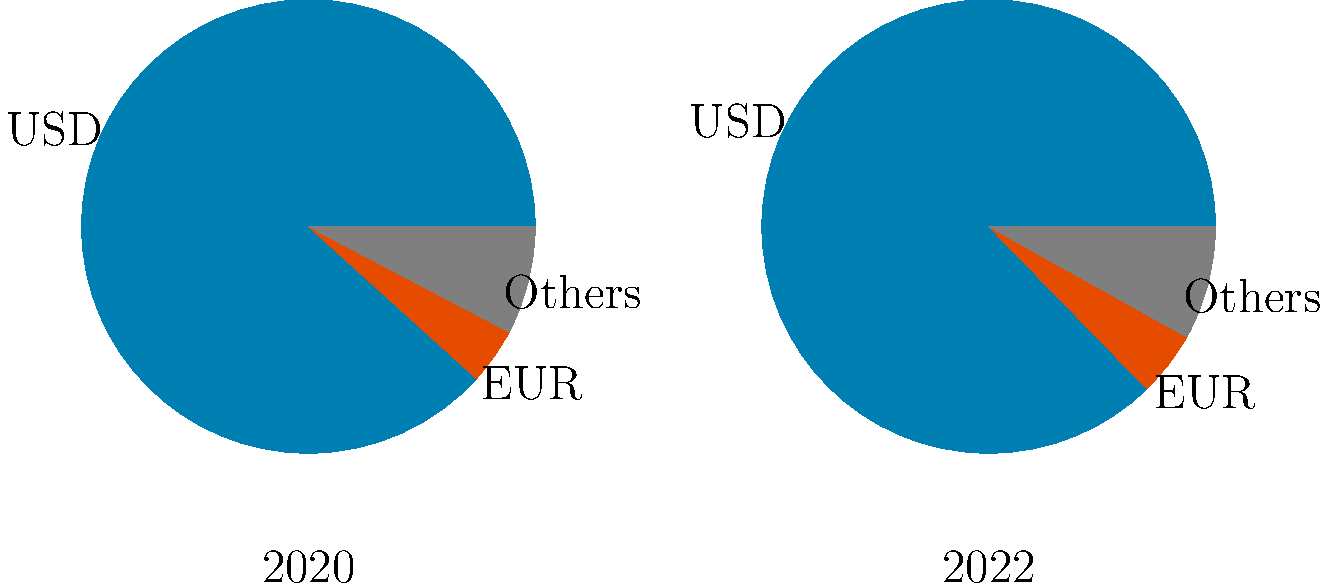Based on the pie charts showing global forex market share by currency for 2020 and 2022, which of the following statements is correct? Let's analyze the pie charts step by step:

1. USD (Blue):
   2020: 88.3%
   2022: 87.3%
   Change: Decreased by 1 percentage point

2. EUR (Orange):
   2020: 4.0%
   2022: 4.6%
   Change: Increased by 0.6 percentage points

3. Others (Gray):
   2020: 7.7%
   2022: 8.1%
   Change: Increased by 0.4 percentage points

Key observations:
- The USD remains the dominant currency in both years, but its share slightly decreased.
- Both EUR and Others categories increased their market share.
- The EUR showed the largest relative increase, growing from 4.0% to 4.6% (a 15% relative increase).
- The overall changes are relatively small, indicating stability in the forex market composition.

Given these observations, the correct statement would be that the EUR showed the largest relative increase in market share between 2020 and 2022.
Answer: EUR showed the largest relative increase in market share. 